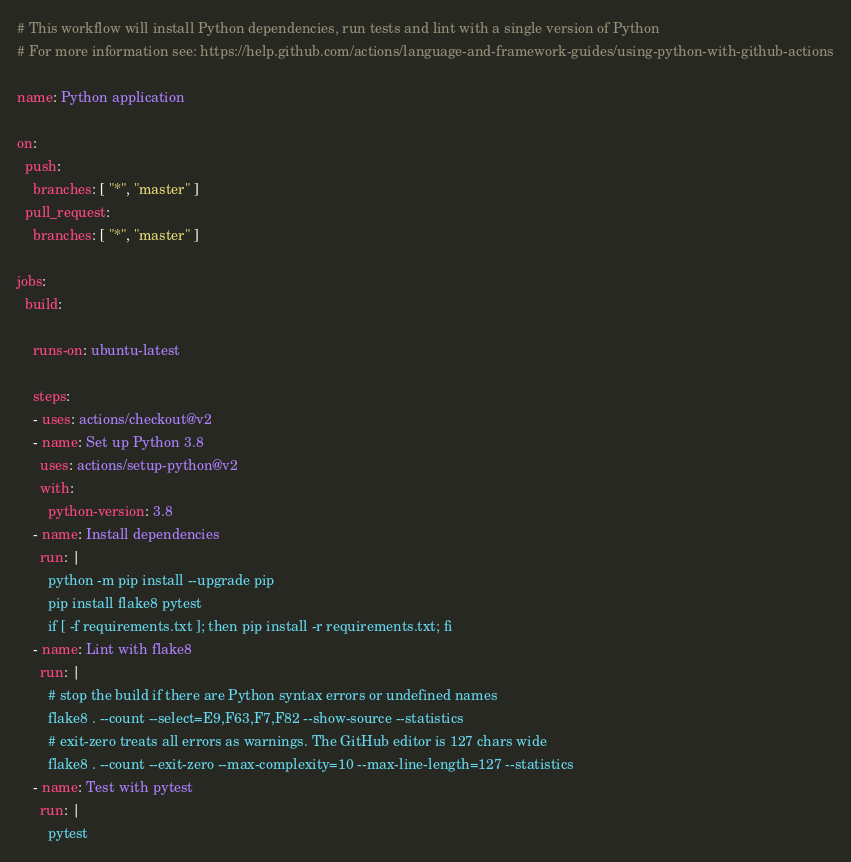<code> <loc_0><loc_0><loc_500><loc_500><_YAML_># This workflow will install Python dependencies, run tests and lint with a single version of Python
# For more information see: https://help.github.com/actions/language-and-framework-guides/using-python-with-github-actions

name: Python application

on:
  push:
    branches: [ "*", "master" ]
  pull_request:
    branches: [ "*", "master" ]

jobs:
  build:

    runs-on: ubuntu-latest

    steps:
    - uses: actions/checkout@v2
    - name: Set up Python 3.8
      uses: actions/setup-python@v2
      with:
        python-version: 3.8
    - name: Install dependencies
      run: |
        python -m pip install --upgrade pip
        pip install flake8 pytest
        if [ -f requirements.txt ]; then pip install -r requirements.txt; fi
    - name: Lint with flake8
      run: |
        # stop the build if there are Python syntax errors or undefined names
        flake8 . --count --select=E9,F63,F7,F82 --show-source --statistics
        # exit-zero treats all errors as warnings. The GitHub editor is 127 chars wide
        flake8 . --count --exit-zero --max-complexity=10 --max-line-length=127 --statistics
    - name: Test with pytest
      run: |
        pytest
</code> 